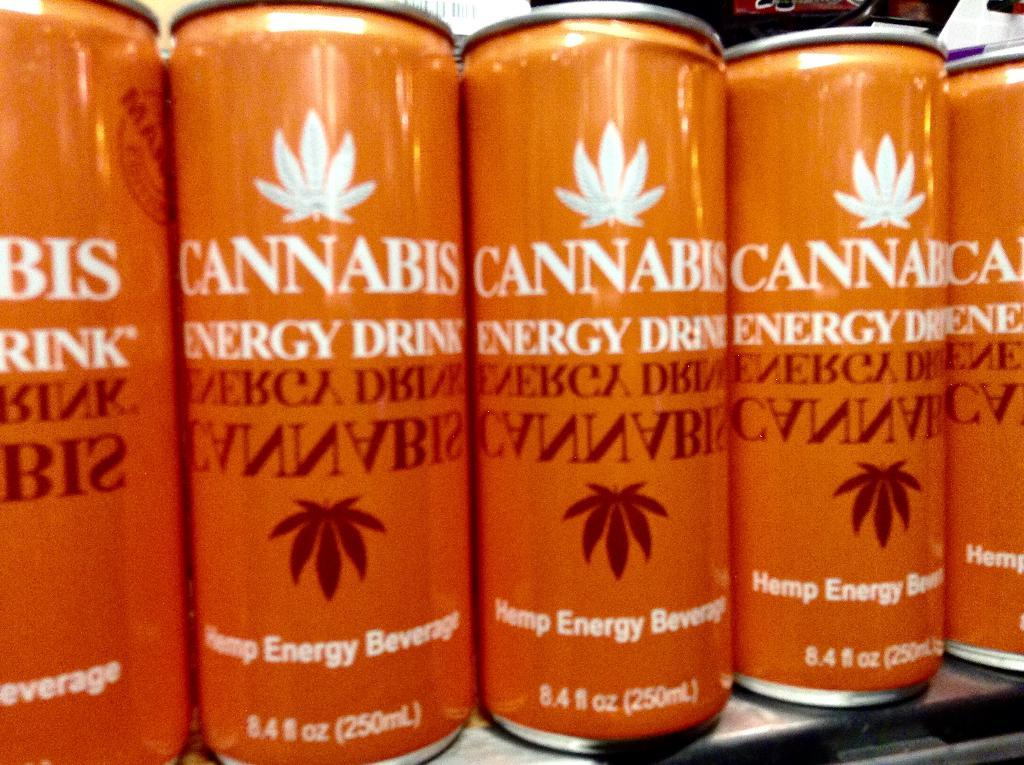<image>
Render a clear and concise summary of the photo. An 8.4 fl oz. orange can of cannabis energy drink. 